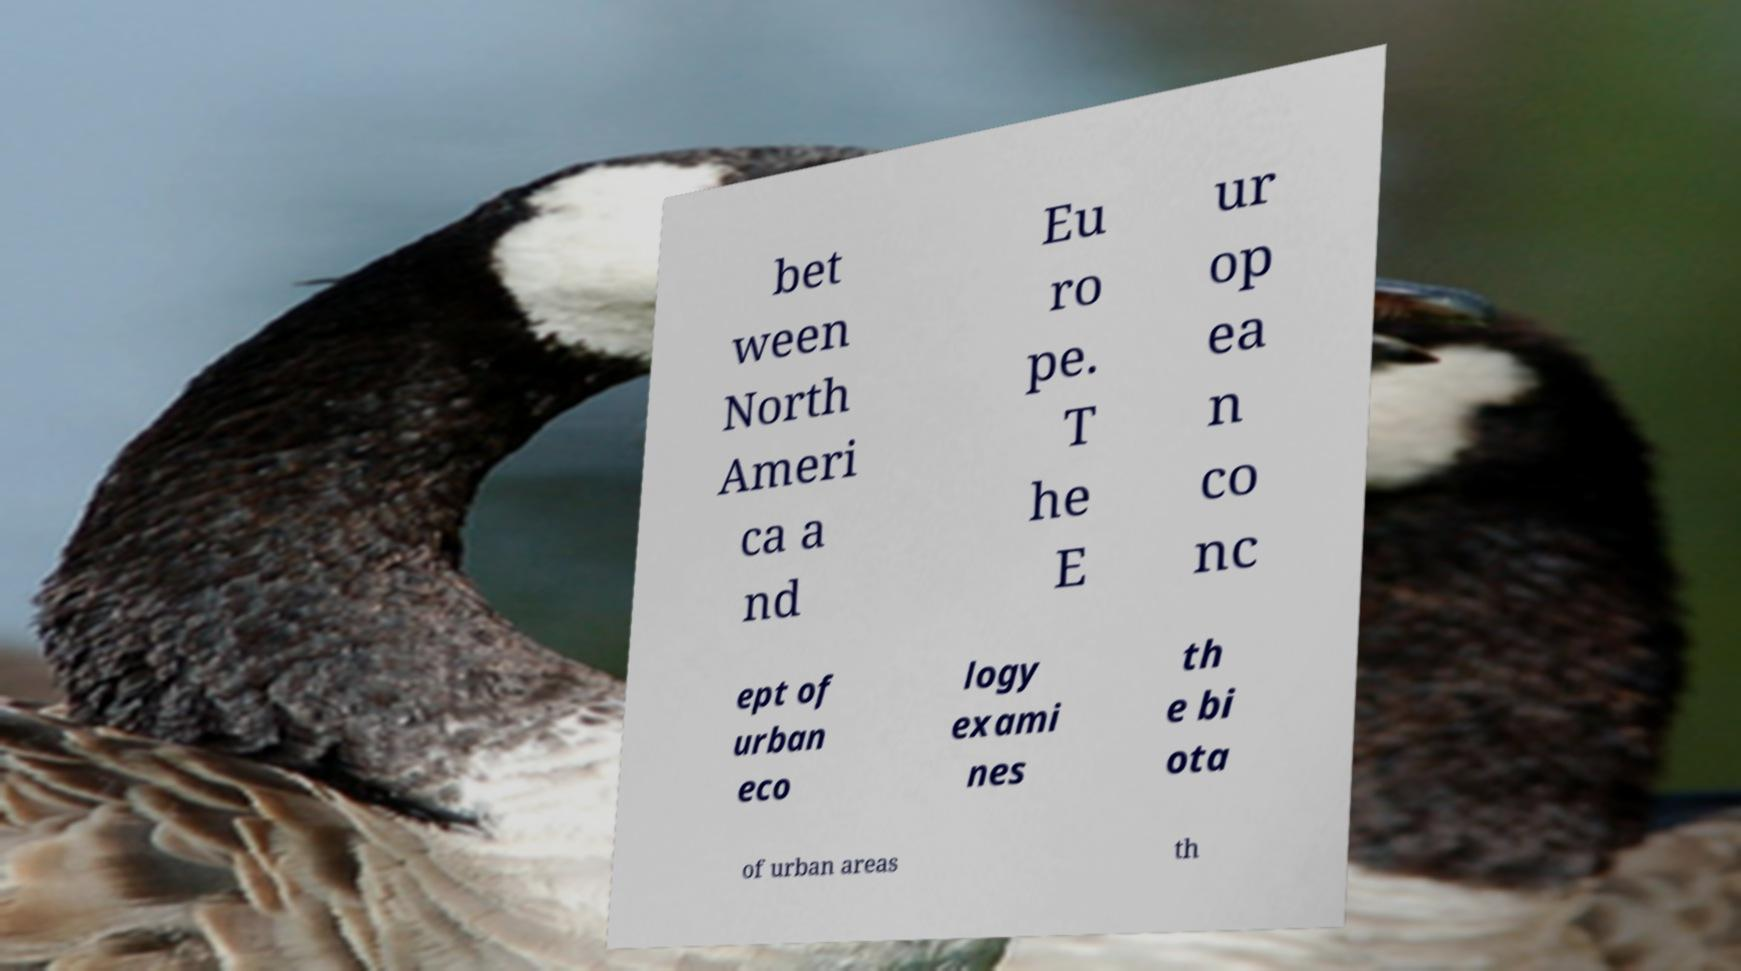Please read and relay the text visible in this image. What does it say? bet ween North Ameri ca a nd Eu ro pe. T he E ur op ea n co nc ept of urban eco logy exami nes th e bi ota of urban areas th 